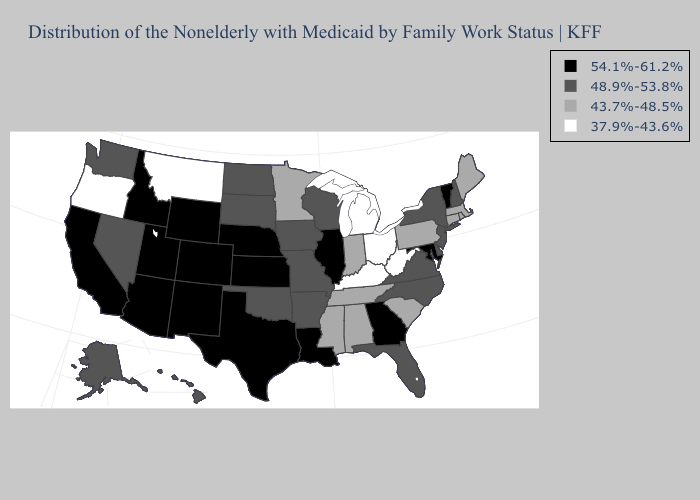What is the value of Nebraska?
Quick response, please. 54.1%-61.2%. Does the map have missing data?
Be succinct. No. What is the highest value in the West ?
Concise answer only. 54.1%-61.2%. What is the lowest value in the South?
Write a very short answer. 37.9%-43.6%. Name the states that have a value in the range 54.1%-61.2%?
Short answer required. Arizona, California, Colorado, Georgia, Idaho, Illinois, Kansas, Louisiana, Maryland, Nebraska, New Mexico, Texas, Utah, Vermont, Wyoming. What is the value of Kentucky?
Write a very short answer. 37.9%-43.6%. Among the states that border Pennsylvania , does West Virginia have the highest value?
Concise answer only. No. What is the highest value in states that border Arkansas?
Write a very short answer. 54.1%-61.2%. Among the states that border California , which have the lowest value?
Quick response, please. Oregon. Does South Dakota have the highest value in the MidWest?
Short answer required. No. Name the states that have a value in the range 54.1%-61.2%?
Give a very brief answer. Arizona, California, Colorado, Georgia, Idaho, Illinois, Kansas, Louisiana, Maryland, Nebraska, New Mexico, Texas, Utah, Vermont, Wyoming. What is the value of South Carolina?
Quick response, please. 43.7%-48.5%. How many symbols are there in the legend?
Be succinct. 4. Does the first symbol in the legend represent the smallest category?
Be succinct. No. Name the states that have a value in the range 43.7%-48.5%?
Write a very short answer. Alabama, Connecticut, Indiana, Maine, Massachusetts, Minnesota, Mississippi, Pennsylvania, Rhode Island, South Carolina, Tennessee. 